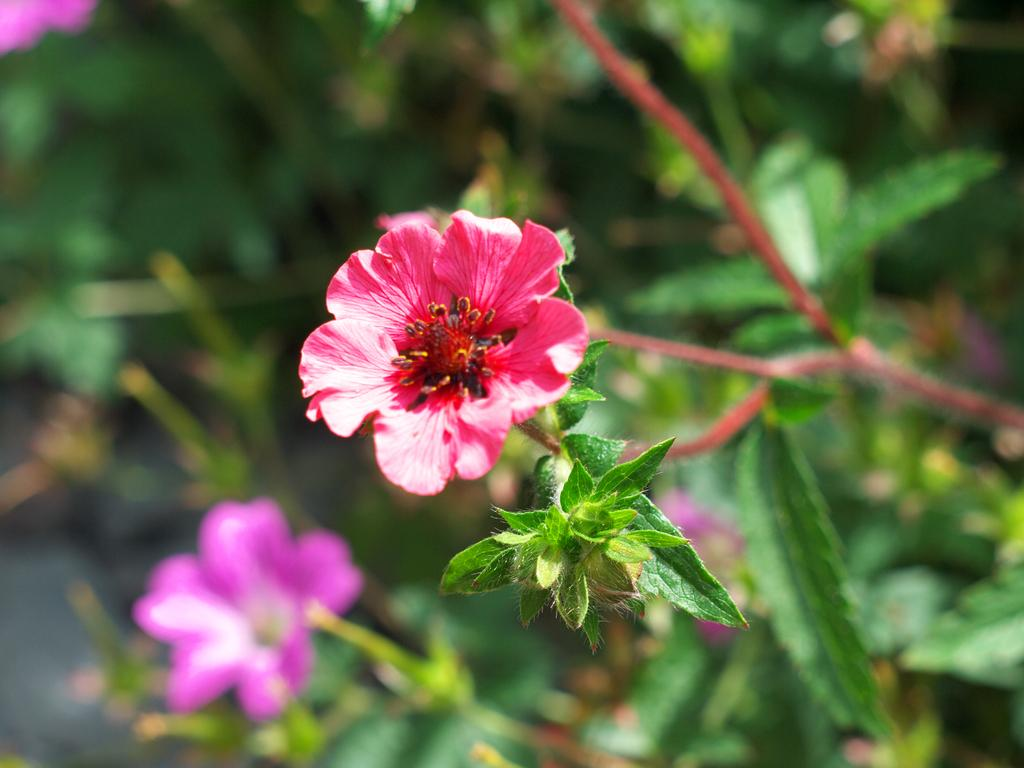What type of plant is visible in the image? There is a flower on a plant in the image. What color is the background of the flower? The background of the flower is blue. What type of wrench is being used by the lawyer in the image? There is no wrench or lawyer present in the image; it features a flower on a plant with a blue background. 